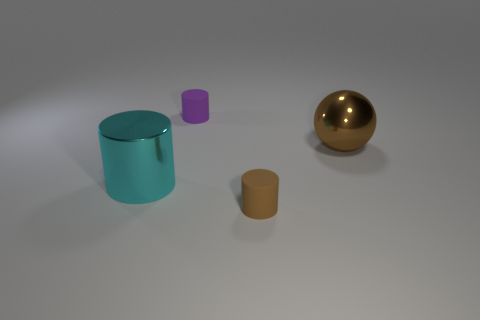There is a rubber thing that is the same color as the big sphere; what is its size?
Provide a short and direct response. Small. What number of other objects are the same color as the large metal ball?
Offer a terse response. 1. What color is the cylinder in front of the big cyan cylinder?
Provide a succinct answer. Brown. There is a brown sphere that is the same size as the cyan metallic object; what material is it?
Your answer should be very brief. Metal. There is a object that is the same color as the metal ball; what is its material?
Your answer should be compact. Rubber. What color is the large sphere that is the same material as the big cylinder?
Give a very brief answer. Brown. Does the cylinder that is to the right of the purple object have the same size as the shiny sphere?
Offer a terse response. No. What is the color of the large thing that is the same shape as the small brown rubber object?
Your response must be concise. Cyan. The tiny rubber object in front of the tiny object left of the cylinder that is in front of the cyan thing is what shape?
Offer a very short reply. Cylinder. Does the brown matte thing have the same shape as the large brown thing?
Keep it short and to the point. No. 